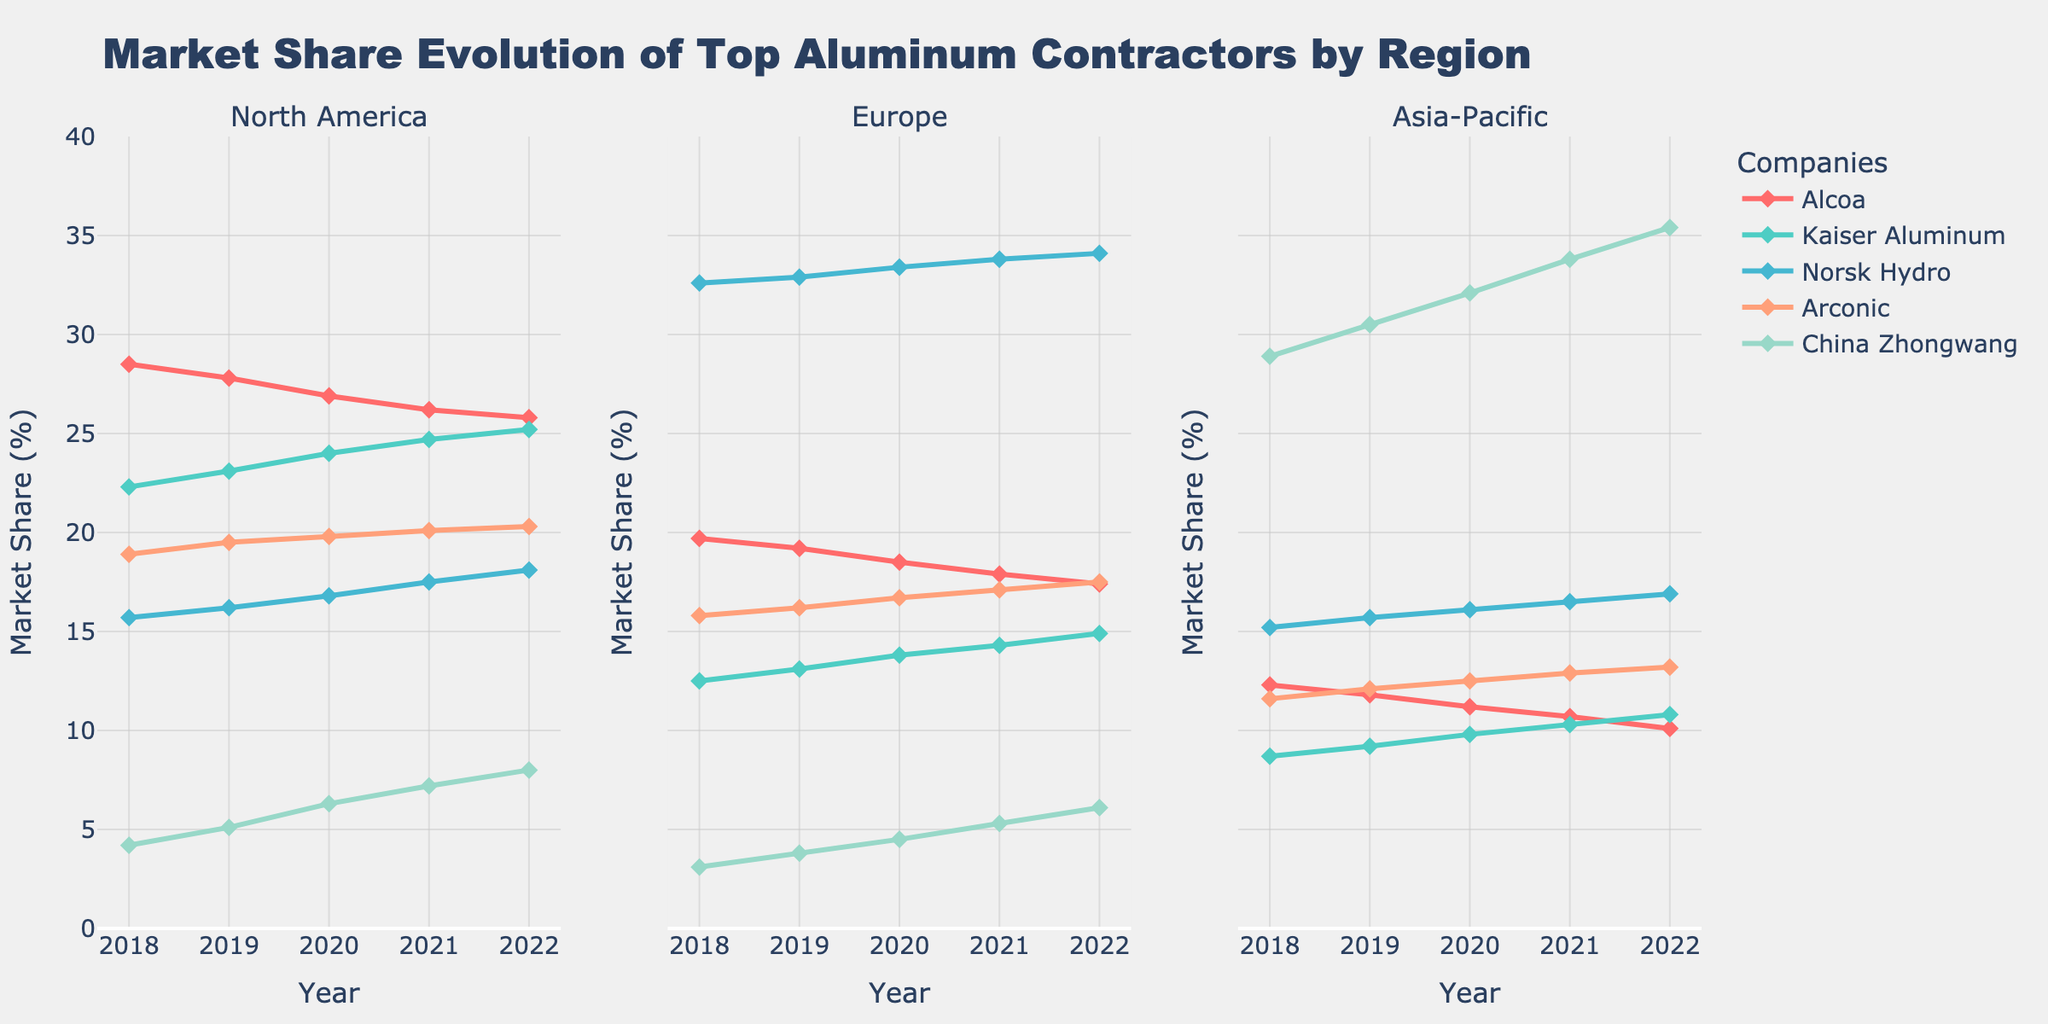How many regions are included in the figure? The titles of the subplots in the figure indicate each region.
Answer: Three What is the title of the figure? The title is placed at the top center of the figure. It summarises what the plot is about.
Answer: "Market Share Evolution of Top Aluminum Contractors by Region" Which company had the highest market share in North America in 2020? In the North America subplot, locate the year 2020 and identify the highest point among the companies.
Answer: Kaiser Aluminum How did the market share of Alcoa change in Europe from 2018 to 2022? Observe the Alcoa line in the Europe subplot and compare the starting point in 2018 to the ending point in 2022.
Answer: Decreased Which region saw the highest increase in market share for China Zhongwang from 2018 to 2022? Compare the trend lines for China Zhongwang in all three subplots from 2018 to 2022 to find where the increase is steepest.
Answer: Asia-Pacific What's the combined market share of Kaiser Aluminum and Norsk Hydro in North America in 2022? Look at both companies' market shares in the North America subplot for the year 2022 and add them up.
Answer: 25.2 + 18.1 = 43.3% Which company has a steadily increasing market share across all regions? Verify each company's trend line in all three subplots; the company with consistently upward lines across all regions fits this criterion.
Answer: China Zhongwang Compare Alcoa's market share trend in North America and Asia-Pacific. Which region saw a faster decline? Analyze the slope of Alcoa's trend line in both regions; a steeper negative slope indicates a faster decline.
Answer: Asia-Pacific In which year did Arconic surpass Alcoa in Europe? In the Europe subplot, find the year where Arconic's line crosses above Alcoa's line.
Answer: 2021 Who had a higher market share in the Asia-Pacific region in 2018, Kaiser Aluminum or Arconic? Check the Asia-Pacific subplot for 2018 and compare the values of Kaiser Aluminum and Arconic.
Answer: Arconic 